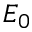Convert formula to latex. <formula><loc_0><loc_0><loc_500><loc_500>E _ { 0 }</formula> 